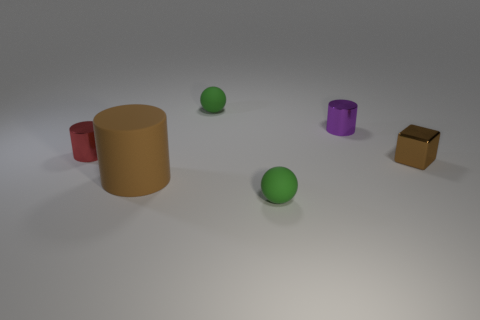Are there any other things that are the same shape as the tiny brown thing?
Offer a terse response. No. How many other purple things are the same material as the purple thing?
Provide a short and direct response. 0. What number of things are either yellow matte spheres or balls in front of the small brown shiny block?
Provide a short and direct response. 1. Do the small green ball in front of the tiny red metallic thing and the large thing have the same material?
Provide a short and direct response. Yes. There is a metallic cylinder that is the same size as the red thing; what color is it?
Provide a short and direct response. Purple. Is there a purple metal thing that has the same shape as the large brown object?
Give a very brief answer. Yes. There is a tiny metallic cylinder on the left side of the tiny green rubber thing behind the green object that is in front of the big brown rubber thing; what is its color?
Keep it short and to the point. Red. How many matte objects are either big gray cylinders or spheres?
Provide a short and direct response. 2. Is the number of rubber things that are behind the big brown cylinder greater than the number of metallic cubes left of the metallic cube?
Keep it short and to the point. Yes. What number of other things are there of the same size as the brown block?
Give a very brief answer. 4. 